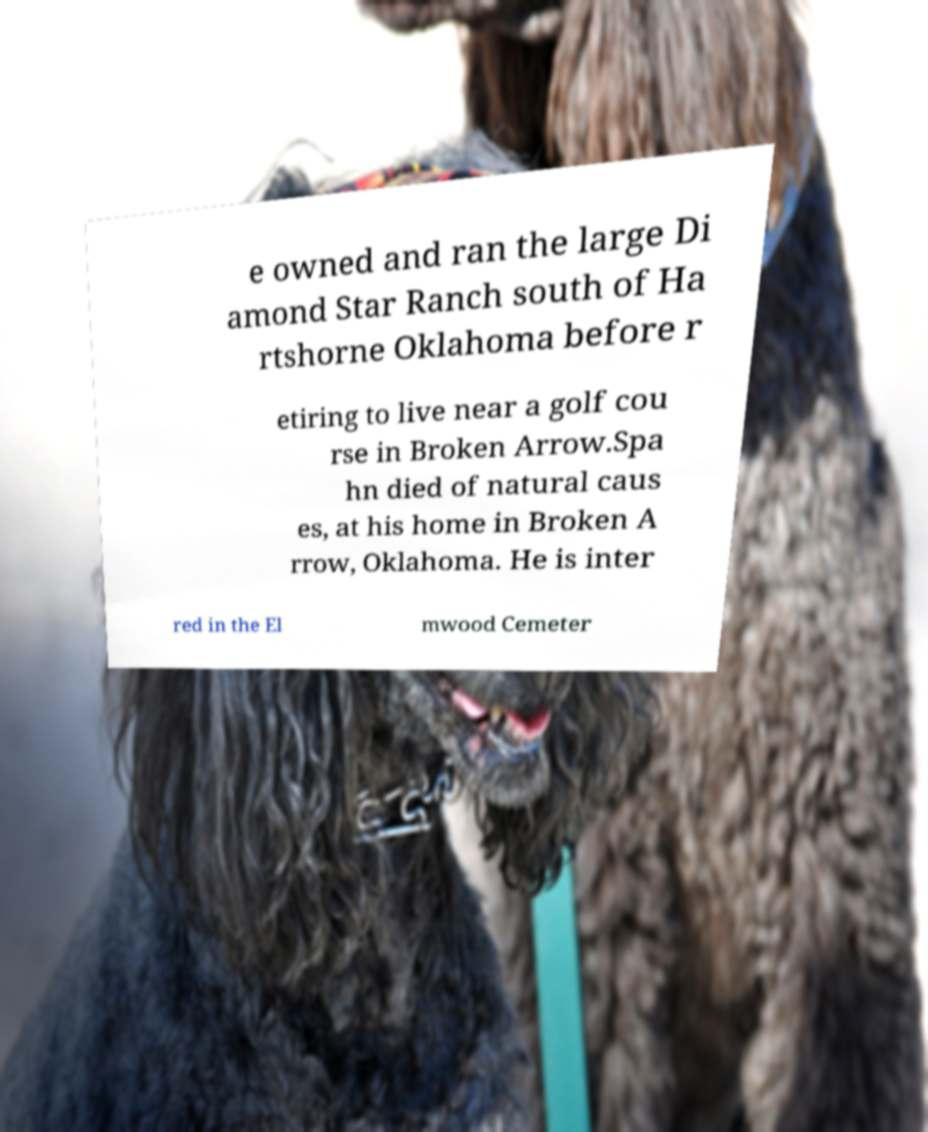What messages or text are displayed in this image? I need them in a readable, typed format. e owned and ran the large Di amond Star Ranch south of Ha rtshorne Oklahoma before r etiring to live near a golf cou rse in Broken Arrow.Spa hn died of natural caus es, at his home in Broken A rrow, Oklahoma. He is inter red in the El mwood Cemeter 